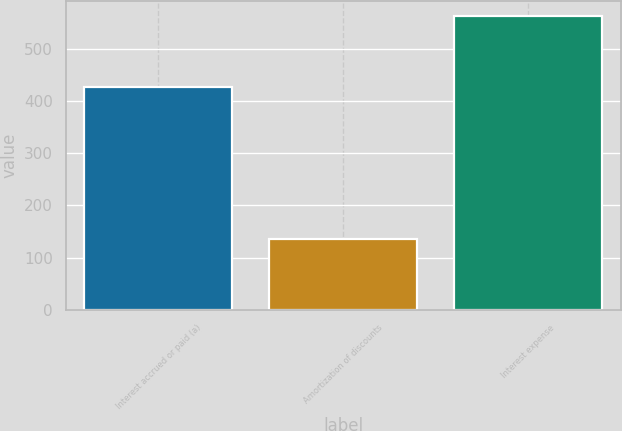Convert chart. <chart><loc_0><loc_0><loc_500><loc_500><bar_chart><fcel>Interest accrued or paid (a)<fcel>Amortization of discounts<fcel>Interest expense<nl><fcel>427<fcel>136<fcel>563<nl></chart> 